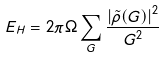<formula> <loc_0><loc_0><loc_500><loc_500>E _ { H } = 2 \pi \Omega \sum _ { G } \frac { \left | \tilde { \rho } ( { G } ) \right | ^ { 2 } } { G ^ { 2 } }</formula> 